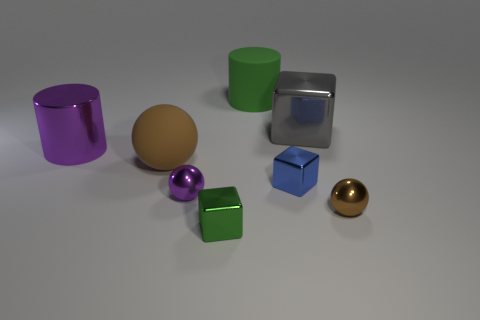There is a block behind the large purple metal cylinder; what number of purple balls are in front of it?
Give a very brief answer. 1. There is a tiny blue thing that is the same shape as the gray thing; what is its material?
Make the answer very short. Metal. What number of purple objects are big shiny cubes or big metal objects?
Offer a terse response. 1. Is there anything else of the same color as the rubber cylinder?
Give a very brief answer. Yes. The object in front of the shiny sphere that is on the right side of the green cylinder is what color?
Your answer should be very brief. Green. Is the number of rubber things on the left side of the big green matte cylinder less than the number of things right of the small purple sphere?
Offer a terse response. Yes. There is a cube that is the same color as the large rubber cylinder; what is it made of?
Provide a succinct answer. Metal. How many things are large things behind the big sphere or tiny yellow blocks?
Offer a terse response. 3. Do the brown object that is to the left of the green metallic cube and the gray object have the same size?
Provide a succinct answer. Yes. Is the number of green blocks that are behind the purple cylinder less than the number of tiny brown rubber cubes?
Keep it short and to the point. No. 